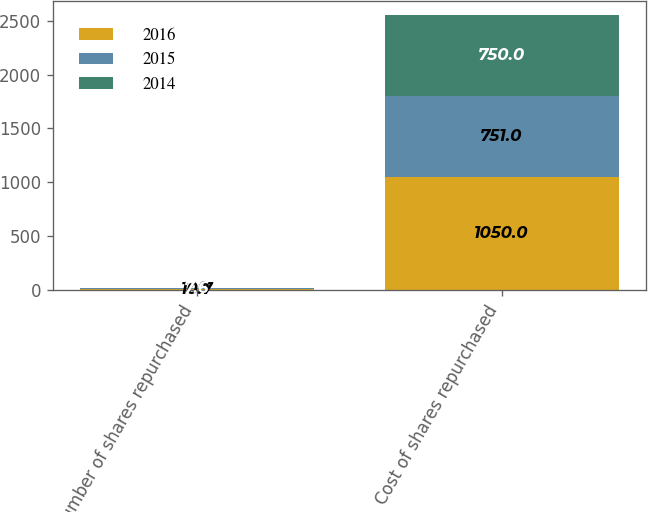<chart> <loc_0><loc_0><loc_500><loc_500><stacked_bar_chart><ecel><fcel>Number of shares repurchased<fcel>Cost of shares repurchased<nl><fcel>2016<fcel>10.7<fcel>1050<nl><fcel>2015<fcel>7<fcel>751<nl><fcel>2014<fcel>7.6<fcel>750<nl></chart> 